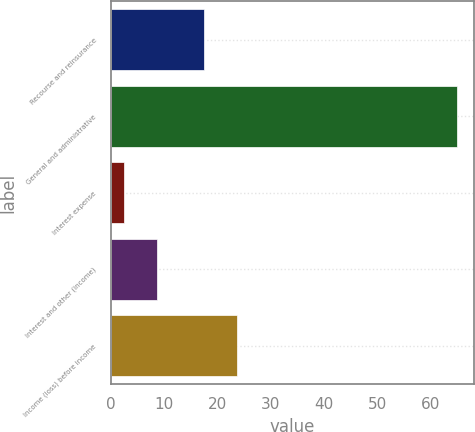<chart> <loc_0><loc_0><loc_500><loc_500><bar_chart><fcel>Recourse and reinsurance<fcel>General and administrative<fcel>Interest expense<fcel>Interest and other (income)<fcel>Income (loss) before income<nl><fcel>17.4<fcel>64.9<fcel>2.4<fcel>8.65<fcel>23.65<nl></chart> 